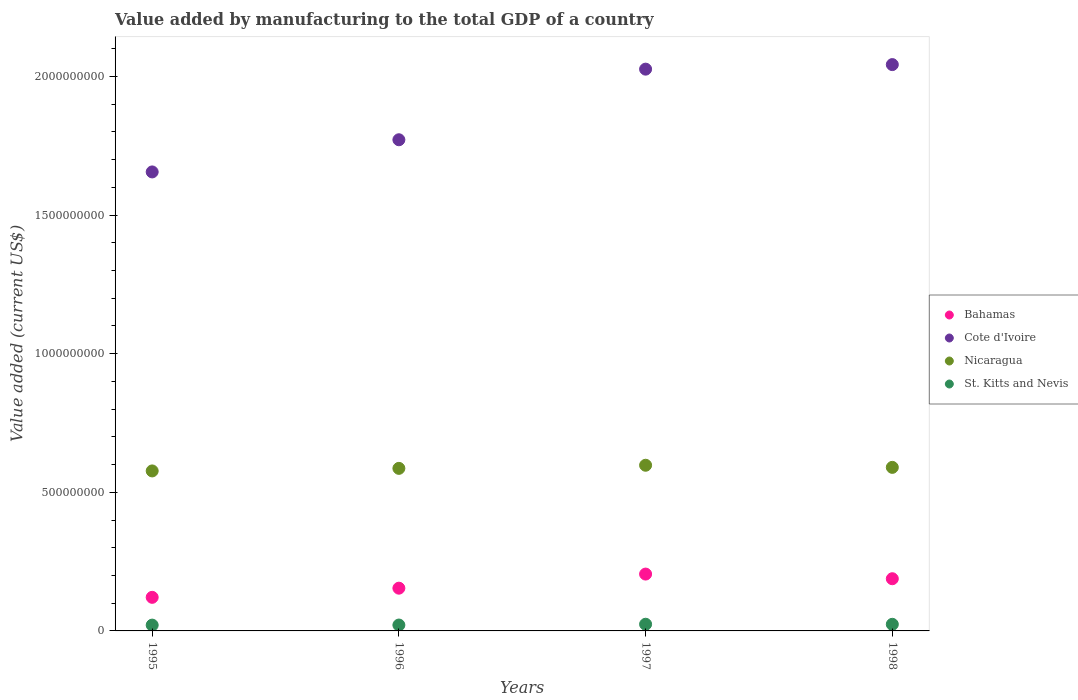What is the value added by manufacturing to the total GDP in St. Kitts and Nevis in 1996?
Give a very brief answer. 2.12e+07. Across all years, what is the maximum value added by manufacturing to the total GDP in St. Kitts and Nevis?
Your answer should be compact. 2.41e+07. Across all years, what is the minimum value added by manufacturing to the total GDP in Cote d'Ivoire?
Provide a short and direct response. 1.66e+09. In which year was the value added by manufacturing to the total GDP in Bahamas minimum?
Keep it short and to the point. 1995. What is the total value added by manufacturing to the total GDP in Cote d'Ivoire in the graph?
Provide a succinct answer. 7.50e+09. What is the difference between the value added by manufacturing to the total GDP in St. Kitts and Nevis in 1997 and that in 1998?
Give a very brief answer. 2.63e+05. What is the difference between the value added by manufacturing to the total GDP in Bahamas in 1997 and the value added by manufacturing to the total GDP in Cote d'Ivoire in 1996?
Offer a very short reply. -1.57e+09. What is the average value added by manufacturing to the total GDP in Bahamas per year?
Provide a succinct answer. 1.67e+08. In the year 1996, what is the difference between the value added by manufacturing to the total GDP in Bahamas and value added by manufacturing to the total GDP in Nicaragua?
Your answer should be very brief. -4.32e+08. In how many years, is the value added by manufacturing to the total GDP in St. Kitts and Nevis greater than 700000000 US$?
Keep it short and to the point. 0. What is the ratio of the value added by manufacturing to the total GDP in St. Kitts and Nevis in 1995 to that in 1996?
Make the answer very short. 0.99. What is the difference between the highest and the second highest value added by manufacturing to the total GDP in Bahamas?
Provide a short and direct response. 1.68e+07. What is the difference between the highest and the lowest value added by manufacturing to the total GDP in Nicaragua?
Offer a terse response. 2.05e+07. Is the value added by manufacturing to the total GDP in Bahamas strictly greater than the value added by manufacturing to the total GDP in Cote d'Ivoire over the years?
Provide a short and direct response. No. How many dotlines are there?
Ensure brevity in your answer.  4. What is the difference between two consecutive major ticks on the Y-axis?
Your answer should be very brief. 5.00e+08. Are the values on the major ticks of Y-axis written in scientific E-notation?
Your answer should be compact. No. Does the graph contain grids?
Keep it short and to the point. No. Where does the legend appear in the graph?
Your answer should be compact. Center right. How many legend labels are there?
Your answer should be compact. 4. How are the legend labels stacked?
Provide a short and direct response. Vertical. What is the title of the graph?
Make the answer very short. Value added by manufacturing to the total GDP of a country. What is the label or title of the X-axis?
Your answer should be very brief. Years. What is the label or title of the Y-axis?
Make the answer very short. Value added (current US$). What is the Value added (current US$) in Bahamas in 1995?
Ensure brevity in your answer.  1.21e+08. What is the Value added (current US$) of Cote d'Ivoire in 1995?
Your answer should be very brief. 1.66e+09. What is the Value added (current US$) of Nicaragua in 1995?
Keep it short and to the point. 5.77e+08. What is the Value added (current US$) of St. Kitts and Nevis in 1995?
Provide a succinct answer. 2.09e+07. What is the Value added (current US$) in Bahamas in 1996?
Provide a succinct answer. 1.54e+08. What is the Value added (current US$) in Cote d'Ivoire in 1996?
Keep it short and to the point. 1.77e+09. What is the Value added (current US$) of Nicaragua in 1996?
Your answer should be compact. 5.86e+08. What is the Value added (current US$) of St. Kitts and Nevis in 1996?
Provide a short and direct response. 2.12e+07. What is the Value added (current US$) in Bahamas in 1997?
Make the answer very short. 2.05e+08. What is the Value added (current US$) of Cote d'Ivoire in 1997?
Your response must be concise. 2.03e+09. What is the Value added (current US$) in Nicaragua in 1997?
Ensure brevity in your answer.  5.98e+08. What is the Value added (current US$) in St. Kitts and Nevis in 1997?
Your answer should be very brief. 2.41e+07. What is the Value added (current US$) in Bahamas in 1998?
Provide a short and direct response. 1.88e+08. What is the Value added (current US$) in Cote d'Ivoire in 1998?
Make the answer very short. 2.04e+09. What is the Value added (current US$) in Nicaragua in 1998?
Give a very brief answer. 5.90e+08. What is the Value added (current US$) of St. Kitts and Nevis in 1998?
Provide a short and direct response. 2.38e+07. Across all years, what is the maximum Value added (current US$) of Bahamas?
Provide a succinct answer. 2.05e+08. Across all years, what is the maximum Value added (current US$) of Cote d'Ivoire?
Give a very brief answer. 2.04e+09. Across all years, what is the maximum Value added (current US$) in Nicaragua?
Provide a short and direct response. 5.98e+08. Across all years, what is the maximum Value added (current US$) in St. Kitts and Nevis?
Keep it short and to the point. 2.41e+07. Across all years, what is the minimum Value added (current US$) in Bahamas?
Give a very brief answer. 1.21e+08. Across all years, what is the minimum Value added (current US$) of Cote d'Ivoire?
Your answer should be very brief. 1.66e+09. Across all years, what is the minimum Value added (current US$) of Nicaragua?
Provide a succinct answer. 5.77e+08. Across all years, what is the minimum Value added (current US$) in St. Kitts and Nevis?
Your response must be concise. 2.09e+07. What is the total Value added (current US$) in Bahamas in the graph?
Give a very brief answer. 6.69e+08. What is the total Value added (current US$) of Cote d'Ivoire in the graph?
Your answer should be very brief. 7.50e+09. What is the total Value added (current US$) in Nicaragua in the graph?
Give a very brief answer. 2.35e+09. What is the total Value added (current US$) in St. Kitts and Nevis in the graph?
Make the answer very short. 9.01e+07. What is the difference between the Value added (current US$) in Bahamas in 1995 and that in 1996?
Give a very brief answer. -3.30e+07. What is the difference between the Value added (current US$) in Cote d'Ivoire in 1995 and that in 1996?
Your answer should be very brief. -1.16e+08. What is the difference between the Value added (current US$) in Nicaragua in 1995 and that in 1996?
Give a very brief answer. -9.22e+06. What is the difference between the Value added (current US$) of St. Kitts and Nevis in 1995 and that in 1996?
Keep it short and to the point. -2.93e+05. What is the difference between the Value added (current US$) in Bahamas in 1995 and that in 1997?
Give a very brief answer. -8.39e+07. What is the difference between the Value added (current US$) in Cote d'Ivoire in 1995 and that in 1997?
Your answer should be compact. -3.71e+08. What is the difference between the Value added (current US$) of Nicaragua in 1995 and that in 1997?
Give a very brief answer. -2.05e+07. What is the difference between the Value added (current US$) in St. Kitts and Nevis in 1995 and that in 1997?
Offer a terse response. -3.17e+06. What is the difference between the Value added (current US$) of Bahamas in 1995 and that in 1998?
Give a very brief answer. -6.71e+07. What is the difference between the Value added (current US$) in Cote d'Ivoire in 1995 and that in 1998?
Offer a very short reply. -3.87e+08. What is the difference between the Value added (current US$) in Nicaragua in 1995 and that in 1998?
Keep it short and to the point. -1.28e+07. What is the difference between the Value added (current US$) of St. Kitts and Nevis in 1995 and that in 1998?
Make the answer very short. -2.91e+06. What is the difference between the Value added (current US$) in Bahamas in 1996 and that in 1997?
Give a very brief answer. -5.09e+07. What is the difference between the Value added (current US$) of Cote d'Ivoire in 1996 and that in 1997?
Provide a short and direct response. -2.55e+08. What is the difference between the Value added (current US$) of Nicaragua in 1996 and that in 1997?
Your answer should be compact. -1.13e+07. What is the difference between the Value added (current US$) in St. Kitts and Nevis in 1996 and that in 1997?
Make the answer very short. -2.88e+06. What is the difference between the Value added (current US$) in Bahamas in 1996 and that in 1998?
Provide a succinct answer. -3.41e+07. What is the difference between the Value added (current US$) of Cote d'Ivoire in 1996 and that in 1998?
Keep it short and to the point. -2.71e+08. What is the difference between the Value added (current US$) in Nicaragua in 1996 and that in 1998?
Your response must be concise. -3.60e+06. What is the difference between the Value added (current US$) in St. Kitts and Nevis in 1996 and that in 1998?
Your answer should be very brief. -2.62e+06. What is the difference between the Value added (current US$) in Bahamas in 1997 and that in 1998?
Make the answer very short. 1.68e+07. What is the difference between the Value added (current US$) of Cote d'Ivoire in 1997 and that in 1998?
Offer a terse response. -1.64e+07. What is the difference between the Value added (current US$) in Nicaragua in 1997 and that in 1998?
Keep it short and to the point. 7.65e+06. What is the difference between the Value added (current US$) of St. Kitts and Nevis in 1997 and that in 1998?
Your response must be concise. 2.63e+05. What is the difference between the Value added (current US$) in Bahamas in 1995 and the Value added (current US$) in Cote d'Ivoire in 1996?
Keep it short and to the point. -1.65e+09. What is the difference between the Value added (current US$) of Bahamas in 1995 and the Value added (current US$) of Nicaragua in 1996?
Provide a short and direct response. -4.65e+08. What is the difference between the Value added (current US$) of Bahamas in 1995 and the Value added (current US$) of St. Kitts and Nevis in 1996?
Keep it short and to the point. 9.99e+07. What is the difference between the Value added (current US$) in Cote d'Ivoire in 1995 and the Value added (current US$) in Nicaragua in 1996?
Offer a very short reply. 1.07e+09. What is the difference between the Value added (current US$) in Cote d'Ivoire in 1995 and the Value added (current US$) in St. Kitts and Nevis in 1996?
Your response must be concise. 1.63e+09. What is the difference between the Value added (current US$) of Nicaragua in 1995 and the Value added (current US$) of St. Kitts and Nevis in 1996?
Offer a terse response. 5.56e+08. What is the difference between the Value added (current US$) of Bahamas in 1995 and the Value added (current US$) of Cote d'Ivoire in 1997?
Your answer should be compact. -1.91e+09. What is the difference between the Value added (current US$) of Bahamas in 1995 and the Value added (current US$) of Nicaragua in 1997?
Your answer should be compact. -4.76e+08. What is the difference between the Value added (current US$) in Bahamas in 1995 and the Value added (current US$) in St. Kitts and Nevis in 1997?
Make the answer very short. 9.70e+07. What is the difference between the Value added (current US$) of Cote d'Ivoire in 1995 and the Value added (current US$) of Nicaragua in 1997?
Your response must be concise. 1.06e+09. What is the difference between the Value added (current US$) of Cote d'Ivoire in 1995 and the Value added (current US$) of St. Kitts and Nevis in 1997?
Provide a succinct answer. 1.63e+09. What is the difference between the Value added (current US$) of Nicaragua in 1995 and the Value added (current US$) of St. Kitts and Nevis in 1997?
Provide a short and direct response. 5.53e+08. What is the difference between the Value added (current US$) of Bahamas in 1995 and the Value added (current US$) of Cote d'Ivoire in 1998?
Offer a very short reply. -1.92e+09. What is the difference between the Value added (current US$) in Bahamas in 1995 and the Value added (current US$) in Nicaragua in 1998?
Your response must be concise. -4.69e+08. What is the difference between the Value added (current US$) in Bahamas in 1995 and the Value added (current US$) in St. Kitts and Nevis in 1998?
Make the answer very short. 9.73e+07. What is the difference between the Value added (current US$) of Cote d'Ivoire in 1995 and the Value added (current US$) of Nicaragua in 1998?
Give a very brief answer. 1.07e+09. What is the difference between the Value added (current US$) of Cote d'Ivoire in 1995 and the Value added (current US$) of St. Kitts and Nevis in 1998?
Provide a short and direct response. 1.63e+09. What is the difference between the Value added (current US$) in Nicaragua in 1995 and the Value added (current US$) in St. Kitts and Nevis in 1998?
Provide a succinct answer. 5.53e+08. What is the difference between the Value added (current US$) in Bahamas in 1996 and the Value added (current US$) in Cote d'Ivoire in 1997?
Your answer should be very brief. -1.87e+09. What is the difference between the Value added (current US$) of Bahamas in 1996 and the Value added (current US$) of Nicaragua in 1997?
Offer a very short reply. -4.43e+08. What is the difference between the Value added (current US$) of Bahamas in 1996 and the Value added (current US$) of St. Kitts and Nevis in 1997?
Ensure brevity in your answer.  1.30e+08. What is the difference between the Value added (current US$) in Cote d'Ivoire in 1996 and the Value added (current US$) in Nicaragua in 1997?
Make the answer very short. 1.17e+09. What is the difference between the Value added (current US$) of Cote d'Ivoire in 1996 and the Value added (current US$) of St. Kitts and Nevis in 1997?
Your answer should be compact. 1.75e+09. What is the difference between the Value added (current US$) in Nicaragua in 1996 and the Value added (current US$) in St. Kitts and Nevis in 1997?
Ensure brevity in your answer.  5.62e+08. What is the difference between the Value added (current US$) in Bahamas in 1996 and the Value added (current US$) in Cote d'Ivoire in 1998?
Provide a succinct answer. -1.89e+09. What is the difference between the Value added (current US$) of Bahamas in 1996 and the Value added (current US$) of Nicaragua in 1998?
Your answer should be very brief. -4.36e+08. What is the difference between the Value added (current US$) of Bahamas in 1996 and the Value added (current US$) of St. Kitts and Nevis in 1998?
Provide a short and direct response. 1.30e+08. What is the difference between the Value added (current US$) of Cote d'Ivoire in 1996 and the Value added (current US$) of Nicaragua in 1998?
Ensure brevity in your answer.  1.18e+09. What is the difference between the Value added (current US$) in Cote d'Ivoire in 1996 and the Value added (current US$) in St. Kitts and Nevis in 1998?
Provide a short and direct response. 1.75e+09. What is the difference between the Value added (current US$) in Nicaragua in 1996 and the Value added (current US$) in St. Kitts and Nevis in 1998?
Offer a very short reply. 5.62e+08. What is the difference between the Value added (current US$) in Bahamas in 1997 and the Value added (current US$) in Cote d'Ivoire in 1998?
Your answer should be very brief. -1.84e+09. What is the difference between the Value added (current US$) in Bahamas in 1997 and the Value added (current US$) in Nicaragua in 1998?
Ensure brevity in your answer.  -3.85e+08. What is the difference between the Value added (current US$) in Bahamas in 1997 and the Value added (current US$) in St. Kitts and Nevis in 1998?
Offer a terse response. 1.81e+08. What is the difference between the Value added (current US$) of Cote d'Ivoire in 1997 and the Value added (current US$) of Nicaragua in 1998?
Your response must be concise. 1.44e+09. What is the difference between the Value added (current US$) in Cote d'Ivoire in 1997 and the Value added (current US$) in St. Kitts and Nevis in 1998?
Keep it short and to the point. 2.00e+09. What is the difference between the Value added (current US$) in Nicaragua in 1997 and the Value added (current US$) in St. Kitts and Nevis in 1998?
Make the answer very short. 5.74e+08. What is the average Value added (current US$) of Bahamas per year?
Your response must be concise. 1.67e+08. What is the average Value added (current US$) of Cote d'Ivoire per year?
Provide a succinct answer. 1.87e+09. What is the average Value added (current US$) in Nicaragua per year?
Offer a very short reply. 5.88e+08. What is the average Value added (current US$) in St. Kitts and Nevis per year?
Provide a short and direct response. 2.25e+07. In the year 1995, what is the difference between the Value added (current US$) in Bahamas and Value added (current US$) in Cote d'Ivoire?
Make the answer very short. -1.53e+09. In the year 1995, what is the difference between the Value added (current US$) in Bahamas and Value added (current US$) in Nicaragua?
Provide a succinct answer. -4.56e+08. In the year 1995, what is the difference between the Value added (current US$) of Bahamas and Value added (current US$) of St. Kitts and Nevis?
Your response must be concise. 1.00e+08. In the year 1995, what is the difference between the Value added (current US$) in Cote d'Ivoire and Value added (current US$) in Nicaragua?
Keep it short and to the point. 1.08e+09. In the year 1995, what is the difference between the Value added (current US$) in Cote d'Ivoire and Value added (current US$) in St. Kitts and Nevis?
Provide a succinct answer. 1.63e+09. In the year 1995, what is the difference between the Value added (current US$) in Nicaragua and Value added (current US$) in St. Kitts and Nevis?
Your answer should be compact. 5.56e+08. In the year 1996, what is the difference between the Value added (current US$) in Bahamas and Value added (current US$) in Cote d'Ivoire?
Your answer should be compact. -1.62e+09. In the year 1996, what is the difference between the Value added (current US$) of Bahamas and Value added (current US$) of Nicaragua?
Your response must be concise. -4.32e+08. In the year 1996, what is the difference between the Value added (current US$) in Bahamas and Value added (current US$) in St. Kitts and Nevis?
Offer a very short reply. 1.33e+08. In the year 1996, what is the difference between the Value added (current US$) of Cote d'Ivoire and Value added (current US$) of Nicaragua?
Provide a succinct answer. 1.19e+09. In the year 1996, what is the difference between the Value added (current US$) of Cote d'Ivoire and Value added (current US$) of St. Kitts and Nevis?
Make the answer very short. 1.75e+09. In the year 1996, what is the difference between the Value added (current US$) of Nicaragua and Value added (current US$) of St. Kitts and Nevis?
Make the answer very short. 5.65e+08. In the year 1997, what is the difference between the Value added (current US$) of Bahamas and Value added (current US$) of Cote d'Ivoire?
Your answer should be compact. -1.82e+09. In the year 1997, what is the difference between the Value added (current US$) of Bahamas and Value added (current US$) of Nicaragua?
Ensure brevity in your answer.  -3.93e+08. In the year 1997, what is the difference between the Value added (current US$) in Bahamas and Value added (current US$) in St. Kitts and Nevis?
Make the answer very short. 1.81e+08. In the year 1997, what is the difference between the Value added (current US$) of Cote d'Ivoire and Value added (current US$) of Nicaragua?
Your response must be concise. 1.43e+09. In the year 1997, what is the difference between the Value added (current US$) in Cote d'Ivoire and Value added (current US$) in St. Kitts and Nevis?
Keep it short and to the point. 2.00e+09. In the year 1997, what is the difference between the Value added (current US$) in Nicaragua and Value added (current US$) in St. Kitts and Nevis?
Offer a very short reply. 5.73e+08. In the year 1998, what is the difference between the Value added (current US$) of Bahamas and Value added (current US$) of Cote d'Ivoire?
Provide a succinct answer. -1.85e+09. In the year 1998, what is the difference between the Value added (current US$) of Bahamas and Value added (current US$) of Nicaragua?
Ensure brevity in your answer.  -4.02e+08. In the year 1998, what is the difference between the Value added (current US$) in Bahamas and Value added (current US$) in St. Kitts and Nevis?
Your answer should be compact. 1.64e+08. In the year 1998, what is the difference between the Value added (current US$) in Cote d'Ivoire and Value added (current US$) in Nicaragua?
Give a very brief answer. 1.45e+09. In the year 1998, what is the difference between the Value added (current US$) of Cote d'Ivoire and Value added (current US$) of St. Kitts and Nevis?
Make the answer very short. 2.02e+09. In the year 1998, what is the difference between the Value added (current US$) in Nicaragua and Value added (current US$) in St. Kitts and Nevis?
Provide a succinct answer. 5.66e+08. What is the ratio of the Value added (current US$) in Bahamas in 1995 to that in 1996?
Keep it short and to the point. 0.79. What is the ratio of the Value added (current US$) in Cote d'Ivoire in 1995 to that in 1996?
Keep it short and to the point. 0.93. What is the ratio of the Value added (current US$) in Nicaragua in 1995 to that in 1996?
Provide a short and direct response. 0.98. What is the ratio of the Value added (current US$) of St. Kitts and Nevis in 1995 to that in 1996?
Your response must be concise. 0.99. What is the ratio of the Value added (current US$) of Bahamas in 1995 to that in 1997?
Offer a terse response. 0.59. What is the ratio of the Value added (current US$) of Cote d'Ivoire in 1995 to that in 1997?
Offer a terse response. 0.82. What is the ratio of the Value added (current US$) of Nicaragua in 1995 to that in 1997?
Offer a very short reply. 0.97. What is the ratio of the Value added (current US$) of St. Kitts and Nevis in 1995 to that in 1997?
Offer a very short reply. 0.87. What is the ratio of the Value added (current US$) of Bahamas in 1995 to that in 1998?
Give a very brief answer. 0.64. What is the ratio of the Value added (current US$) of Cote d'Ivoire in 1995 to that in 1998?
Keep it short and to the point. 0.81. What is the ratio of the Value added (current US$) in Nicaragua in 1995 to that in 1998?
Keep it short and to the point. 0.98. What is the ratio of the Value added (current US$) of St. Kitts and Nevis in 1995 to that in 1998?
Give a very brief answer. 0.88. What is the ratio of the Value added (current US$) in Bahamas in 1996 to that in 1997?
Keep it short and to the point. 0.75. What is the ratio of the Value added (current US$) in Cote d'Ivoire in 1996 to that in 1997?
Offer a very short reply. 0.87. What is the ratio of the Value added (current US$) of Nicaragua in 1996 to that in 1997?
Ensure brevity in your answer.  0.98. What is the ratio of the Value added (current US$) of St. Kitts and Nevis in 1996 to that in 1997?
Provide a succinct answer. 0.88. What is the ratio of the Value added (current US$) of Bahamas in 1996 to that in 1998?
Offer a very short reply. 0.82. What is the ratio of the Value added (current US$) of Cote d'Ivoire in 1996 to that in 1998?
Your answer should be very brief. 0.87. What is the ratio of the Value added (current US$) of Nicaragua in 1996 to that in 1998?
Offer a very short reply. 0.99. What is the ratio of the Value added (current US$) of St. Kitts and Nevis in 1996 to that in 1998?
Offer a very short reply. 0.89. What is the ratio of the Value added (current US$) in Bahamas in 1997 to that in 1998?
Provide a short and direct response. 1.09. What is the ratio of the Value added (current US$) of Nicaragua in 1997 to that in 1998?
Offer a terse response. 1.01. What is the ratio of the Value added (current US$) in St. Kitts and Nevis in 1997 to that in 1998?
Provide a short and direct response. 1.01. What is the difference between the highest and the second highest Value added (current US$) of Bahamas?
Provide a short and direct response. 1.68e+07. What is the difference between the highest and the second highest Value added (current US$) of Cote d'Ivoire?
Provide a short and direct response. 1.64e+07. What is the difference between the highest and the second highest Value added (current US$) of Nicaragua?
Make the answer very short. 7.65e+06. What is the difference between the highest and the second highest Value added (current US$) in St. Kitts and Nevis?
Provide a succinct answer. 2.63e+05. What is the difference between the highest and the lowest Value added (current US$) of Bahamas?
Provide a short and direct response. 8.39e+07. What is the difference between the highest and the lowest Value added (current US$) of Cote d'Ivoire?
Your answer should be compact. 3.87e+08. What is the difference between the highest and the lowest Value added (current US$) in Nicaragua?
Provide a succinct answer. 2.05e+07. What is the difference between the highest and the lowest Value added (current US$) in St. Kitts and Nevis?
Offer a terse response. 3.17e+06. 